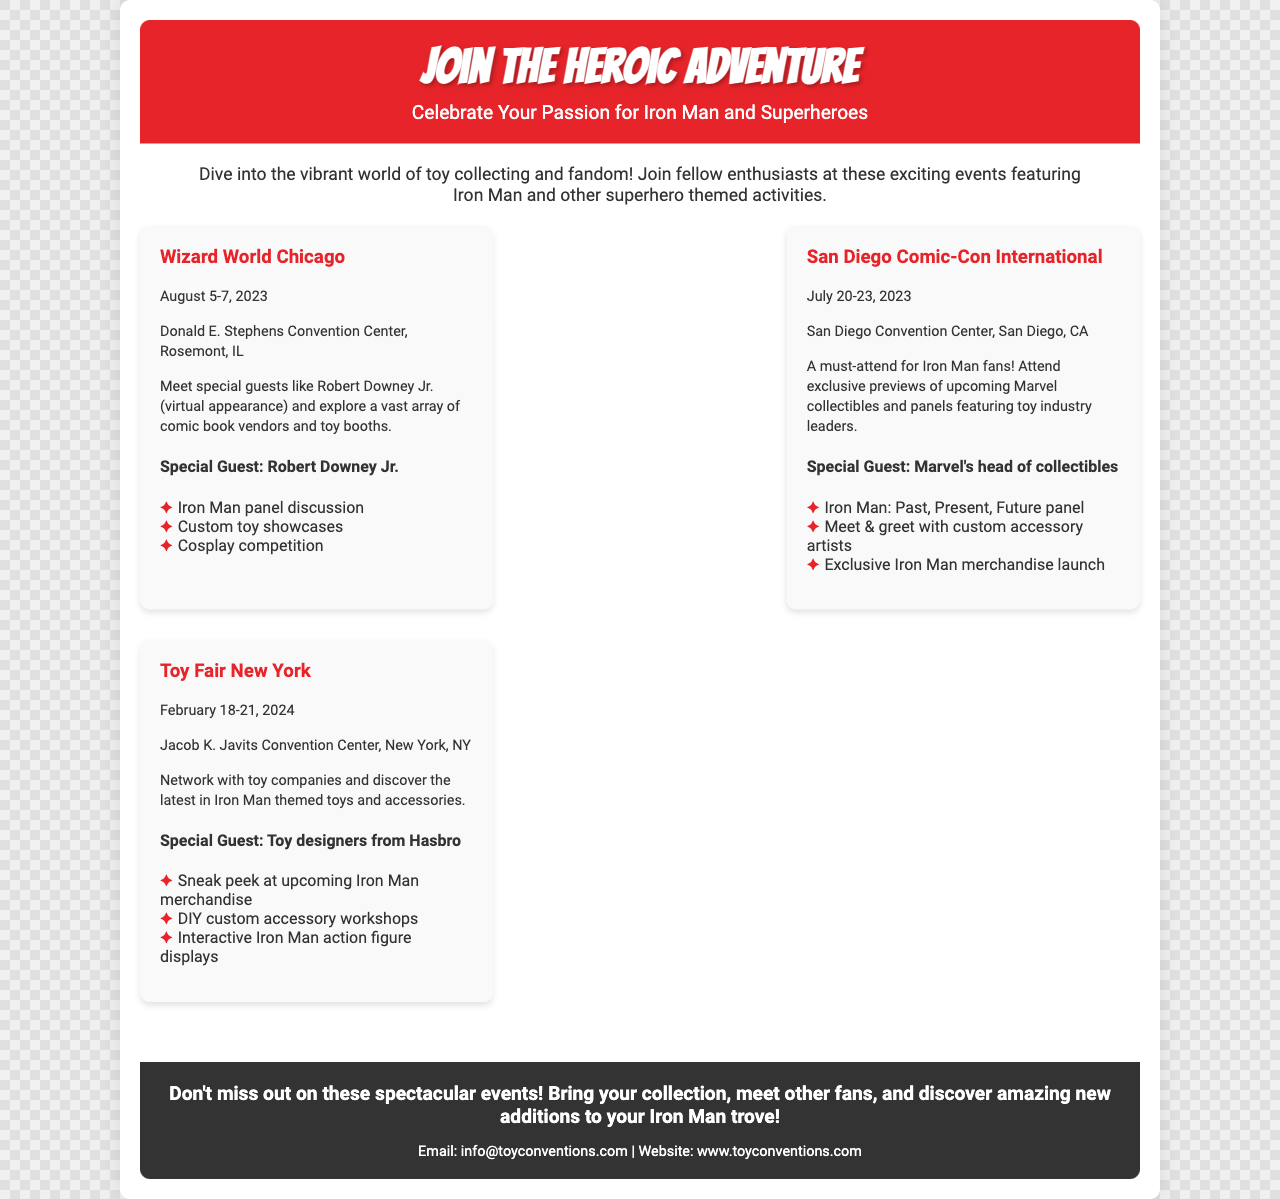What is the date of the Wizard World Chicago? The Wizard World Chicago takes place from August 5-7, 2023.
Answer: August 5-7, 2023 Where is the San Diego Comic-Con International held? The San Diego Comic-Con International is located at the San Diego Convention Center, San Diego, CA.
Answer: San Diego Convention Center, San Diego, CA Who is the special guest at Toy Fair New York? The special guest at Toy Fair New York is toy designers from Hasbro.
Answer: Toy designers from Hasbro What is one of the activities at the San Diego Comic-Con International? One of the activities at the San Diego Comic-Con International is the Iron Man: Past, Present, Future panel.
Answer: Iron Man: Past, Present, Future panel How many days does Toy Fair New York last? Toy Fair New York lasts for four days from February 18-21, 2024.
Answer: Four days What themes do the events in the document focus on? The events focus on Iron Man and other superhero themes.
Answer: Iron Man and other superhero themes What type of competition is featured at Wizard World Chicago? Wizard World Chicago features a cosplay competition.
Answer: Cosplay competition What is the main purpose of the brochure? The main purpose of the brochure is to inform about upcoming toy conventions and events.
Answer: Inform about upcoming toy conventions and events 